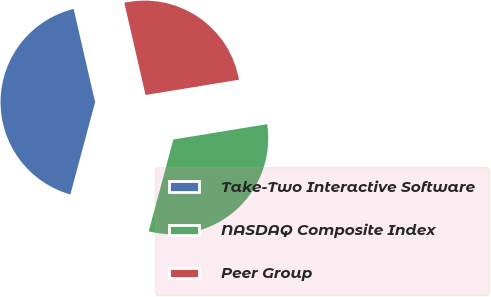Convert chart to OTSL. <chart><loc_0><loc_0><loc_500><loc_500><pie_chart><fcel>Take-Two Interactive Software<fcel>NASDAQ Composite Index<fcel>Peer Group<nl><fcel>42.23%<fcel>31.75%<fcel>26.03%<nl></chart> 